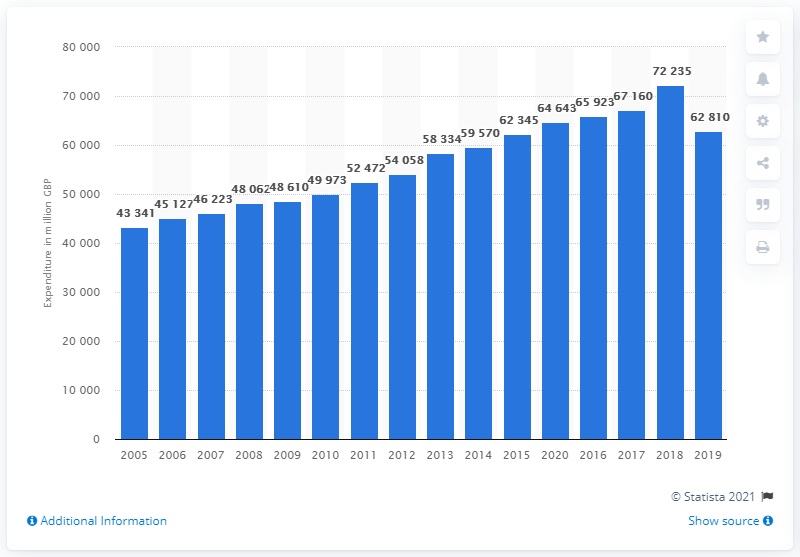How might external factors have influenced the peaks and dips seen in this chart? Various external factors could influence the peaks and dips in the UK apparel and footwear market as seen in the chart. Economic factors such as inflation, employment rates, and disposable income can affect consumer spending. Fashion industry changes, like the rise of fast fashion or sustainable clothing movements, can also sway market values. Additionally, global events such as the financial crisis in 2008 or e-commerce growth may alter shopping behaviors. For a thorough understanding, cross-referencing this data with economic reports and industry analyses of the corresponding years would provide deeper insights. 